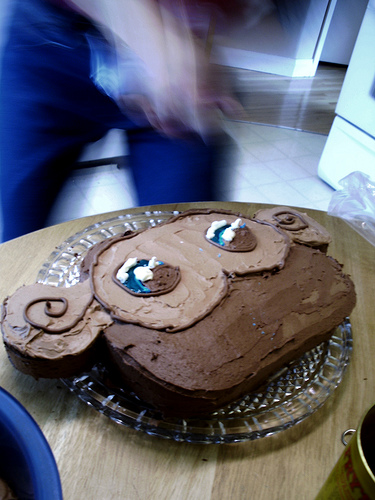<image>
Is the cake on the table? Yes. Looking at the image, I can see the cake is positioned on top of the table, with the table providing support. 